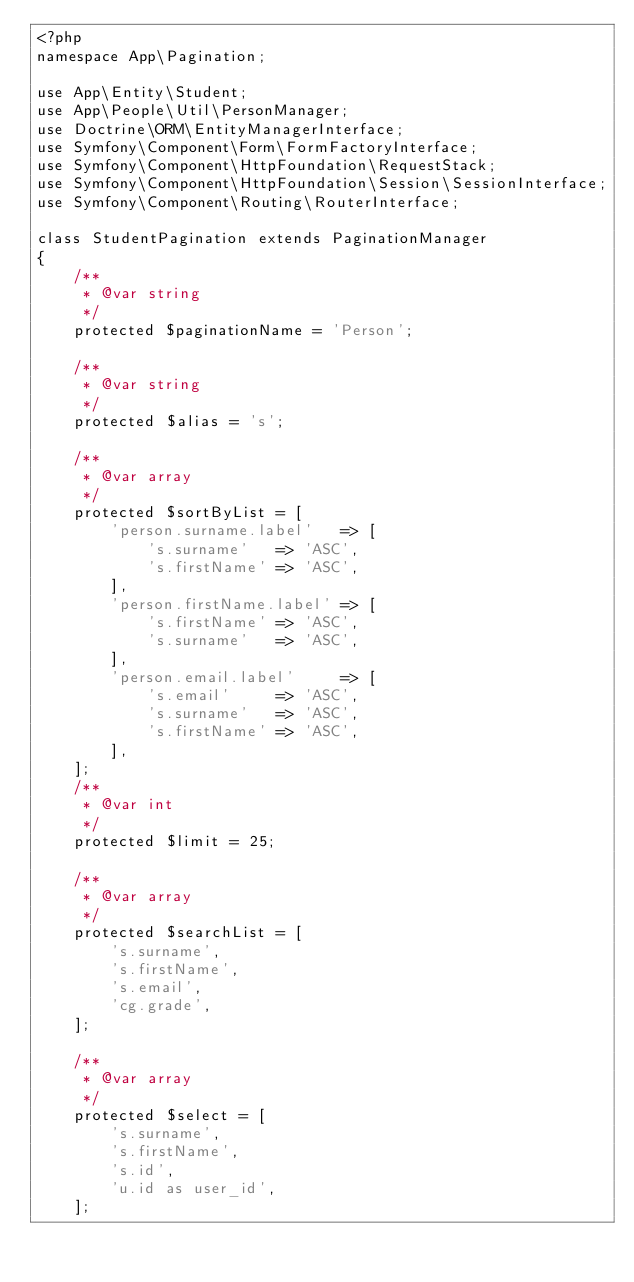<code> <loc_0><loc_0><loc_500><loc_500><_PHP_><?php
namespace App\Pagination;

use App\Entity\Student;
use App\People\Util\PersonManager;
use Doctrine\ORM\EntityManagerInterface;
use Symfony\Component\Form\FormFactoryInterface;
use Symfony\Component\HttpFoundation\RequestStack;
use Symfony\Component\HttpFoundation\Session\SessionInterface;
use Symfony\Component\Routing\RouterInterface;

class StudentPagination extends PaginationManager
{
	/**
	 * @var string
	 */
	protected $paginationName = 'Person';

	/**
	 * @var string
	 */
	protected $alias = 's';

	/**
	 * @var array
	 */
	protected $sortByList = [
		'person.surname.label'   => [
			's.surname'   => 'ASC',
			's.firstName' => 'ASC',
		],
		'person.firstName.label' => [
			's.firstName' => 'ASC',
			's.surname'   => 'ASC',
		],
        'person.email.label'     => [
            's.email'     => 'ASC',
            's.surname'   => 'ASC',
            's.firstName' => 'ASC',
        ],
	];
	/**
	 * @var int
	 */
	protected $limit = 25;

	/**
	 * @var array
	 */
	protected $searchList = [
		's.surname',
		's.firstName',
		's.email',
        'cg.grade',
	];

	/**
	 * @var array
	 */
	protected $select = [
		's.surname',
		's.firstName',
		's.id',
		'u.id as user_id',
	];
</code> 